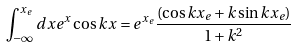<formula> <loc_0><loc_0><loc_500><loc_500>\int ^ { x _ { e } } _ { - \infty } d x e ^ { x } \cos k x = e ^ { x _ { e } } \frac { ( \cos k x _ { e } + k \sin k x _ { e } ) } { 1 + k ^ { 2 } }</formula> 